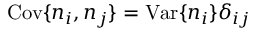<formula> <loc_0><loc_0><loc_500><loc_500>C o v \{ n _ { i } , n _ { j } \} = V a r \{ n _ { i } \} \delta _ { i j }</formula> 